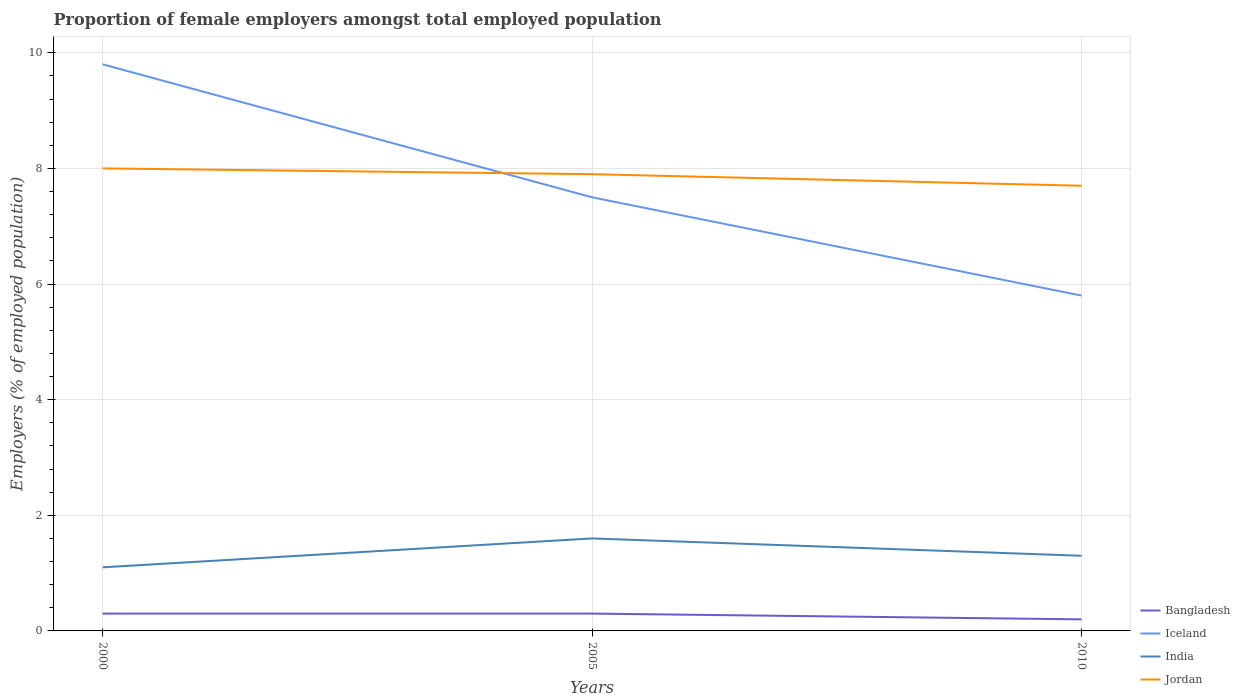Is the number of lines equal to the number of legend labels?
Ensure brevity in your answer.  Yes. Across all years, what is the maximum proportion of female employers in Iceland?
Give a very brief answer. 5.8. In which year was the proportion of female employers in Bangladesh maximum?
Provide a succinct answer. 2010. What is the total proportion of female employers in Jordan in the graph?
Your response must be concise. 0.3. What is the difference between the highest and the second highest proportion of female employers in Bangladesh?
Your answer should be compact. 0.1. What is the difference between two consecutive major ticks on the Y-axis?
Ensure brevity in your answer.  2. Are the values on the major ticks of Y-axis written in scientific E-notation?
Make the answer very short. No. Does the graph contain any zero values?
Your response must be concise. No. Where does the legend appear in the graph?
Ensure brevity in your answer.  Bottom right. How many legend labels are there?
Make the answer very short. 4. How are the legend labels stacked?
Make the answer very short. Vertical. What is the title of the graph?
Offer a terse response. Proportion of female employers amongst total employed population. What is the label or title of the X-axis?
Offer a terse response. Years. What is the label or title of the Y-axis?
Offer a terse response. Employers (% of employed population). What is the Employers (% of employed population) in Bangladesh in 2000?
Your response must be concise. 0.3. What is the Employers (% of employed population) of Iceland in 2000?
Your answer should be very brief. 9.8. What is the Employers (% of employed population) of India in 2000?
Provide a succinct answer. 1.1. What is the Employers (% of employed population) in Jordan in 2000?
Ensure brevity in your answer.  8. What is the Employers (% of employed population) of Bangladesh in 2005?
Keep it short and to the point. 0.3. What is the Employers (% of employed population) of India in 2005?
Keep it short and to the point. 1.6. What is the Employers (% of employed population) of Jordan in 2005?
Provide a succinct answer. 7.9. What is the Employers (% of employed population) of Bangladesh in 2010?
Ensure brevity in your answer.  0.2. What is the Employers (% of employed population) of Iceland in 2010?
Your answer should be very brief. 5.8. What is the Employers (% of employed population) in India in 2010?
Offer a very short reply. 1.3. What is the Employers (% of employed population) in Jordan in 2010?
Keep it short and to the point. 7.7. Across all years, what is the maximum Employers (% of employed population) of Bangladesh?
Offer a very short reply. 0.3. Across all years, what is the maximum Employers (% of employed population) of Iceland?
Offer a terse response. 9.8. Across all years, what is the maximum Employers (% of employed population) of India?
Your response must be concise. 1.6. Across all years, what is the maximum Employers (% of employed population) in Jordan?
Ensure brevity in your answer.  8. Across all years, what is the minimum Employers (% of employed population) of Bangladesh?
Make the answer very short. 0.2. Across all years, what is the minimum Employers (% of employed population) of Iceland?
Offer a very short reply. 5.8. Across all years, what is the minimum Employers (% of employed population) in India?
Keep it short and to the point. 1.1. Across all years, what is the minimum Employers (% of employed population) of Jordan?
Offer a terse response. 7.7. What is the total Employers (% of employed population) of Iceland in the graph?
Your answer should be very brief. 23.1. What is the total Employers (% of employed population) in Jordan in the graph?
Offer a terse response. 23.6. What is the difference between the Employers (% of employed population) in Jordan in 2005 and that in 2010?
Offer a terse response. 0.2. What is the difference between the Employers (% of employed population) of Iceland in 2000 and the Employers (% of employed population) of India in 2005?
Ensure brevity in your answer.  8.2. What is the difference between the Employers (% of employed population) of India in 2000 and the Employers (% of employed population) of Jordan in 2005?
Your answer should be very brief. -6.8. What is the difference between the Employers (% of employed population) in Bangladesh in 2000 and the Employers (% of employed population) in Iceland in 2010?
Ensure brevity in your answer.  -5.5. What is the difference between the Employers (% of employed population) of Bangladesh in 2000 and the Employers (% of employed population) of Jordan in 2010?
Make the answer very short. -7.4. What is the difference between the Employers (% of employed population) in Iceland in 2000 and the Employers (% of employed population) in India in 2010?
Keep it short and to the point. 8.5. What is the difference between the Employers (% of employed population) in Bangladesh in 2005 and the Employers (% of employed population) in India in 2010?
Your answer should be very brief. -1. What is the difference between the Employers (% of employed population) of Iceland in 2005 and the Employers (% of employed population) of India in 2010?
Keep it short and to the point. 6.2. What is the difference between the Employers (% of employed population) in India in 2005 and the Employers (% of employed population) in Jordan in 2010?
Your answer should be compact. -6.1. What is the average Employers (% of employed population) of Bangladesh per year?
Your answer should be very brief. 0.27. What is the average Employers (% of employed population) of Jordan per year?
Your answer should be very brief. 7.87. In the year 2000, what is the difference between the Employers (% of employed population) in Bangladesh and Employers (% of employed population) in Iceland?
Keep it short and to the point. -9.5. In the year 2005, what is the difference between the Employers (% of employed population) in Bangladesh and Employers (% of employed population) in India?
Provide a succinct answer. -1.3. In the year 2005, what is the difference between the Employers (% of employed population) in Iceland and Employers (% of employed population) in India?
Give a very brief answer. 5.9. In the year 2010, what is the difference between the Employers (% of employed population) in Bangladesh and Employers (% of employed population) in India?
Offer a terse response. -1.1. In the year 2010, what is the difference between the Employers (% of employed population) of India and Employers (% of employed population) of Jordan?
Your answer should be very brief. -6.4. What is the ratio of the Employers (% of employed population) in Iceland in 2000 to that in 2005?
Ensure brevity in your answer.  1.31. What is the ratio of the Employers (% of employed population) of India in 2000 to that in 2005?
Ensure brevity in your answer.  0.69. What is the ratio of the Employers (% of employed population) of Jordan in 2000 to that in 2005?
Make the answer very short. 1.01. What is the ratio of the Employers (% of employed population) of Bangladesh in 2000 to that in 2010?
Provide a succinct answer. 1.5. What is the ratio of the Employers (% of employed population) in Iceland in 2000 to that in 2010?
Offer a very short reply. 1.69. What is the ratio of the Employers (% of employed population) of India in 2000 to that in 2010?
Your answer should be compact. 0.85. What is the ratio of the Employers (% of employed population) in Jordan in 2000 to that in 2010?
Offer a terse response. 1.04. What is the ratio of the Employers (% of employed population) in Bangladesh in 2005 to that in 2010?
Your answer should be compact. 1.5. What is the ratio of the Employers (% of employed population) in Iceland in 2005 to that in 2010?
Your answer should be very brief. 1.29. What is the ratio of the Employers (% of employed population) in India in 2005 to that in 2010?
Provide a short and direct response. 1.23. What is the ratio of the Employers (% of employed population) in Jordan in 2005 to that in 2010?
Ensure brevity in your answer.  1.03. What is the difference between the highest and the second highest Employers (% of employed population) in Bangladesh?
Your answer should be very brief. 0. What is the difference between the highest and the second highest Employers (% of employed population) of Jordan?
Offer a terse response. 0.1. What is the difference between the highest and the lowest Employers (% of employed population) of Iceland?
Offer a very short reply. 4. What is the difference between the highest and the lowest Employers (% of employed population) of Jordan?
Your answer should be very brief. 0.3. 